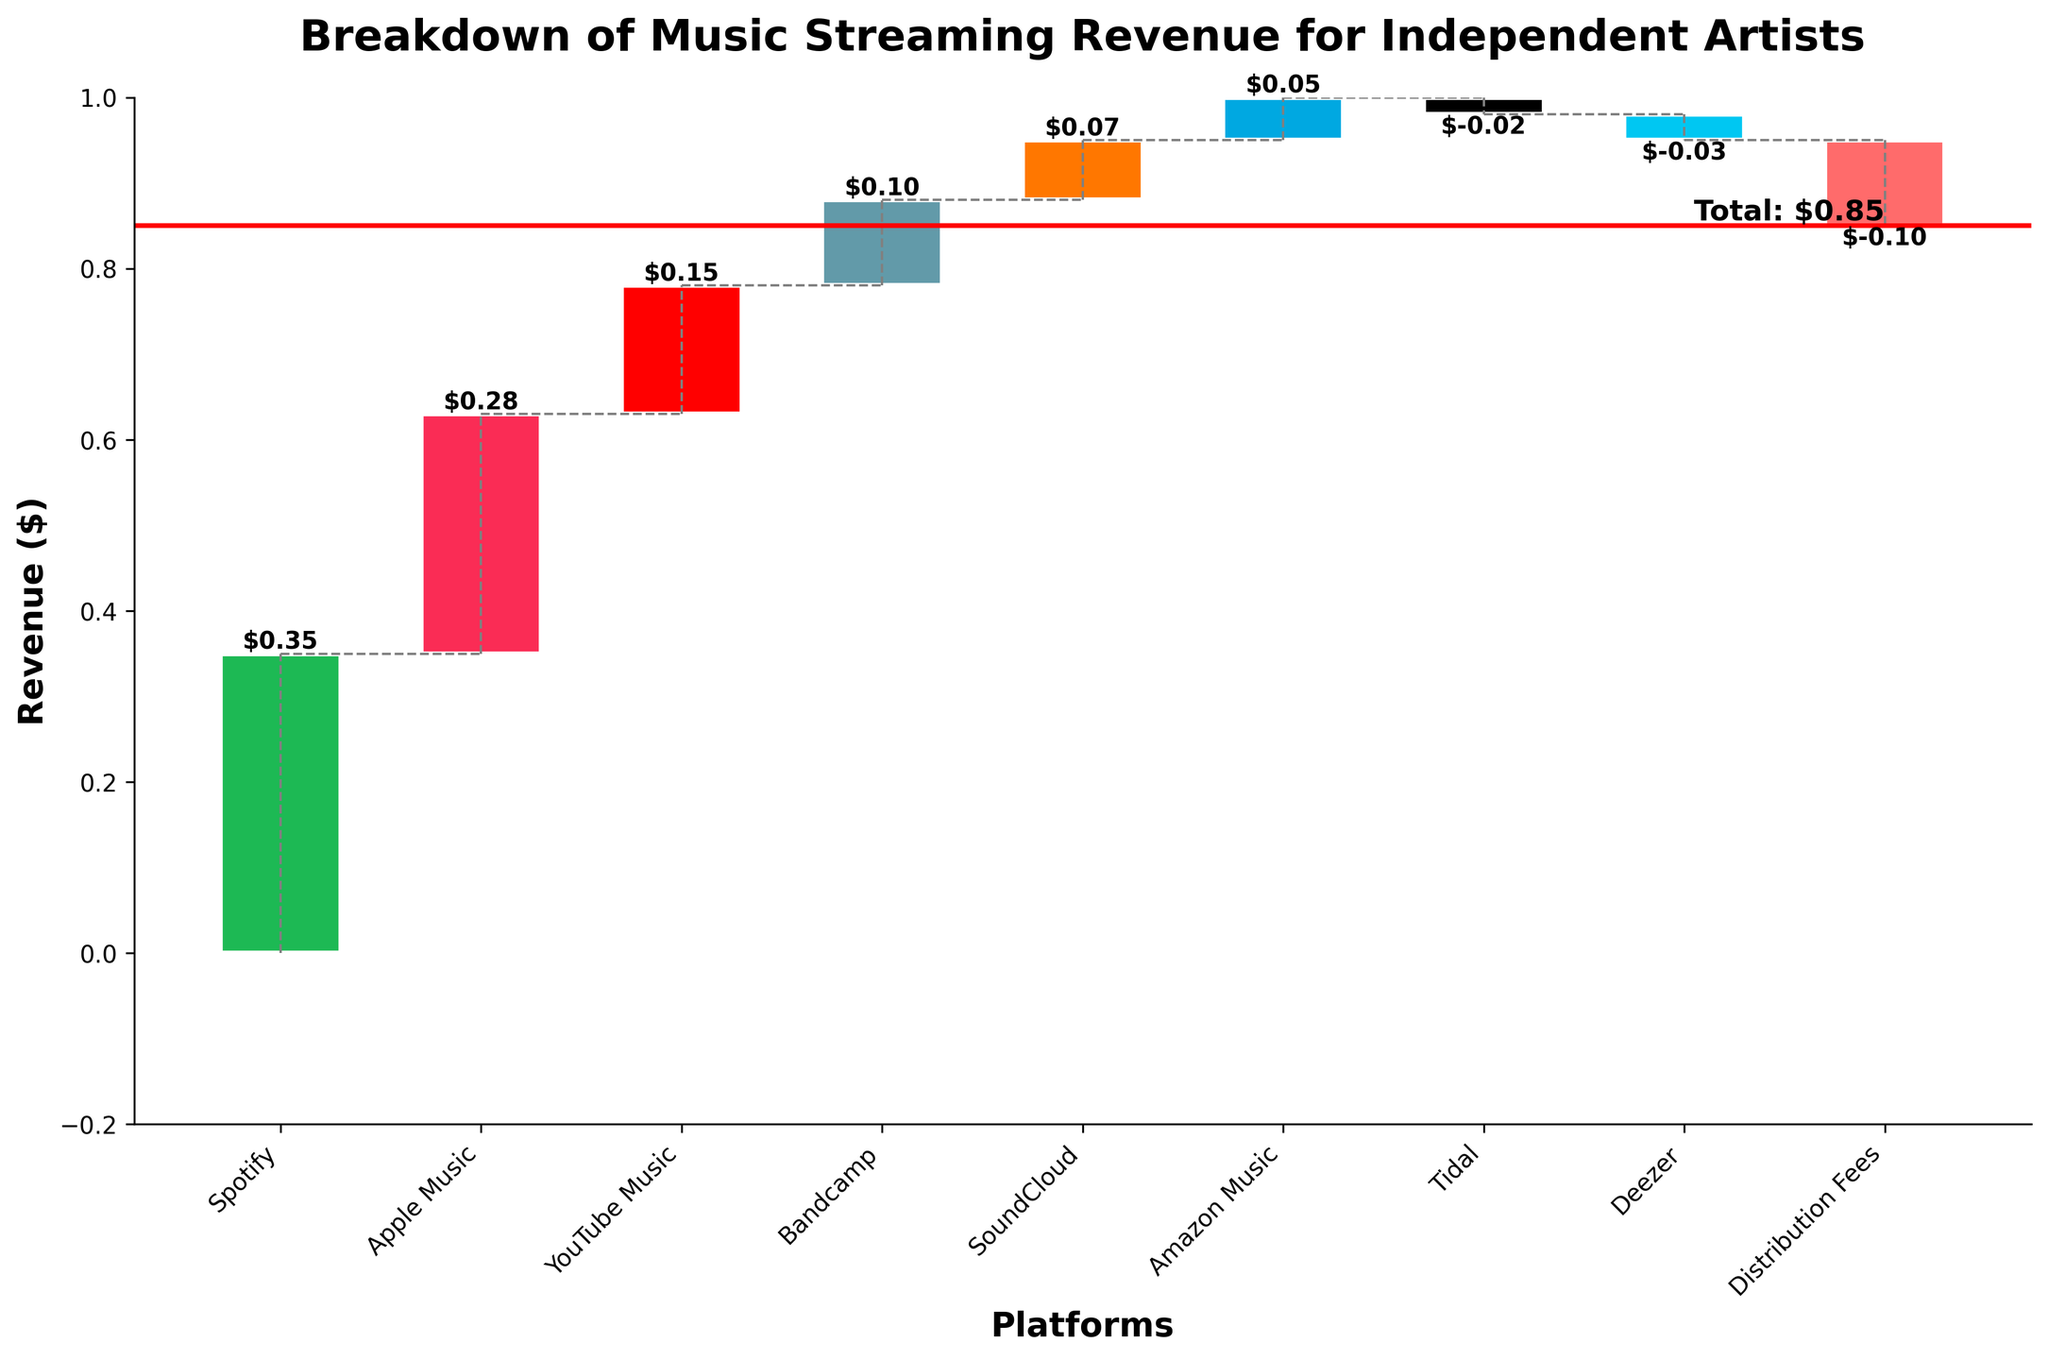How is the total revenue depicted in the chart? The total revenue is depicted as a horizontal red line at the value of $0.85. It is also marked with a text annotation 'Total: $0.85' near the last platform (Deezer).
Answer: A horizontal red line at $0.85 Which platform contributes the highest revenue? The highest bar in the chart represents the highest revenue, which is for Spotify. The value is $0.35, marked above the bar.
Answer: Spotify What is the combined revenue from Apple Music and YouTube Music? Apple Music contributes $0.28 and YouTube Music contributes $0.15. Adding these two values gives $0.28 + $0.15 = $0.43.
Answer: $0.43 Which platforms have a negative contribution to revenue? The bars below the baseline (0) indicate negative contributions. These platforms are Tidal (-$0.02) and Deezer (-$0.03).
Answer: Tidal and Deezer How does the revenue from Bandcamp compare to that from SoundCloud? Bandcamp's revenue is $0.10, whereas SoundCloud's revenue is $0.07. This means Bandcamp contributes more by $0.10 - $0.07 = $0.03.
Answer: Bandcamp contributes $0.03 more What is the impact of distribution fees on the total revenue? Distribution Fees are shown as a negative value of $-0.10, reducing the overall revenue by $0.10.
Answer: Reduces revenue by $0.10 How does Amazon Music's revenue contribution compare to that of Bandcamp and SoundCloud combined? Amazon Music contributes $0.05. Bandcamp and SoundCloud together contribute $0.10 + $0.07 = $0.17. Amazon Music is less by $0.17 - $0.05 = $0.12.
Answer: Amazon Music contributes $0.12 less What is the cumulative revenue up to YouTube Music? Cumulative revenue is calculated by summing up to YouTube Music: $0.35 (Spotify) + $0.28 (Apple Music) + $0.15 (YouTube Music) = $0.78.
Answer: $0.78 Is the total revenue value greater than the individual contributions from any single platform? The total revenue of $0.85 is greater than any individual platform's revenue, with Spotify being the highest individual contribution at $0.35.
Answer: Yes How many platforms have a positive contribution to the revenue? There are 6 platforms with positive contributions: Spotify, Apple Music, YouTube Music, Bandcamp, SoundCloud, and Amazon Music.
Answer: 6 platforms 